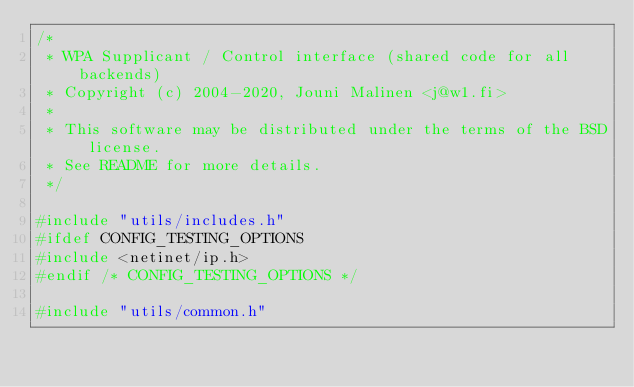Convert code to text. <code><loc_0><loc_0><loc_500><loc_500><_C_>/*
 * WPA Supplicant / Control interface (shared code for all backends)
 * Copyright (c) 2004-2020, Jouni Malinen <j@w1.fi>
 *
 * This software may be distributed under the terms of the BSD license.
 * See README for more details.
 */

#include "utils/includes.h"
#ifdef CONFIG_TESTING_OPTIONS
#include <netinet/ip.h>
#endif /* CONFIG_TESTING_OPTIONS */

#include "utils/common.h"</code> 